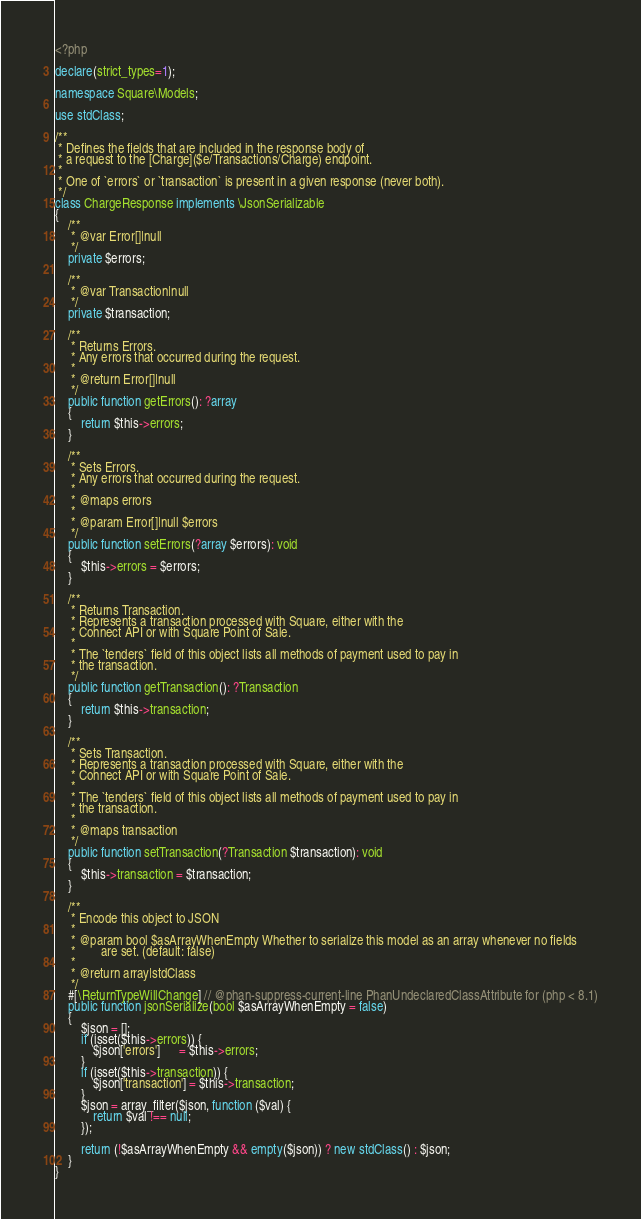<code> <loc_0><loc_0><loc_500><loc_500><_PHP_><?php

declare(strict_types=1);

namespace Square\Models;

use stdClass;

/**
 * Defines the fields that are included in the response body of
 * a request to the [Charge]($e/Transactions/Charge) endpoint.
 *
 * One of `errors` or `transaction` is present in a given response (never both).
 */
class ChargeResponse implements \JsonSerializable
{
    /**
     * @var Error[]|null
     */
    private $errors;

    /**
     * @var Transaction|null
     */
    private $transaction;

    /**
     * Returns Errors.
     * Any errors that occurred during the request.
     *
     * @return Error[]|null
     */
    public function getErrors(): ?array
    {
        return $this->errors;
    }

    /**
     * Sets Errors.
     * Any errors that occurred during the request.
     *
     * @maps errors
     *
     * @param Error[]|null $errors
     */
    public function setErrors(?array $errors): void
    {
        $this->errors = $errors;
    }

    /**
     * Returns Transaction.
     * Represents a transaction processed with Square, either with the
     * Connect API or with Square Point of Sale.
     *
     * The `tenders` field of this object lists all methods of payment used to pay in
     * the transaction.
     */
    public function getTransaction(): ?Transaction
    {
        return $this->transaction;
    }

    /**
     * Sets Transaction.
     * Represents a transaction processed with Square, either with the
     * Connect API or with Square Point of Sale.
     *
     * The `tenders` field of this object lists all methods of payment used to pay in
     * the transaction.
     *
     * @maps transaction
     */
    public function setTransaction(?Transaction $transaction): void
    {
        $this->transaction = $transaction;
    }

    /**
     * Encode this object to JSON
     *
     * @param bool $asArrayWhenEmpty Whether to serialize this model as an array whenever no fields
     *        are set. (default: false)
     *
     * @return array|stdClass
     */
    #[\ReturnTypeWillChange] // @phan-suppress-current-line PhanUndeclaredClassAttribute for (php < 8.1)
    public function jsonSerialize(bool $asArrayWhenEmpty = false)
    {
        $json = [];
        if (isset($this->errors)) {
            $json['errors']      = $this->errors;
        }
        if (isset($this->transaction)) {
            $json['transaction'] = $this->transaction;
        }
        $json = array_filter($json, function ($val) {
            return $val !== null;
        });

        return (!$asArrayWhenEmpty && empty($json)) ? new stdClass() : $json;
    }
}
</code> 